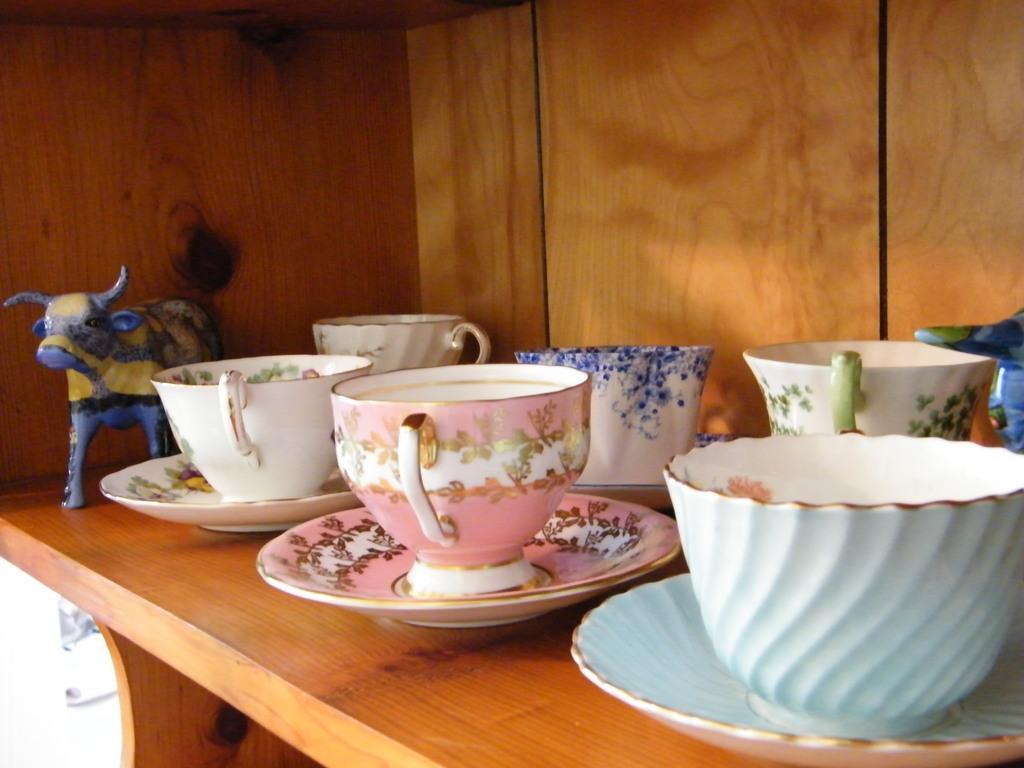Can you describe this image briefly? In the picture there are coffee cups and saucers on a wooden plank,beside that there is a buffalo made of ceramic. 